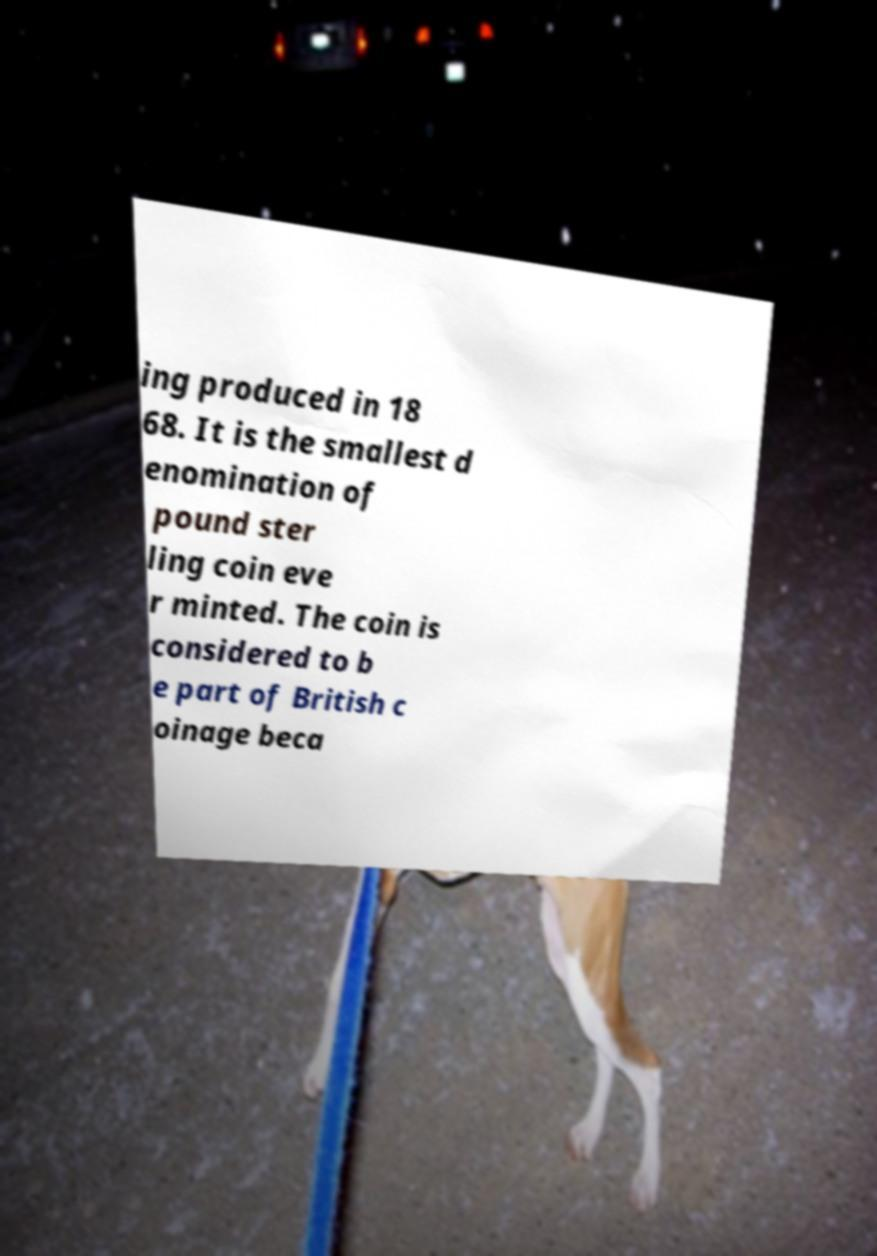What messages or text are displayed in this image? I need them in a readable, typed format. ing produced in 18 68. It is the smallest d enomination of pound ster ling coin eve r minted. The coin is considered to b e part of British c oinage beca 